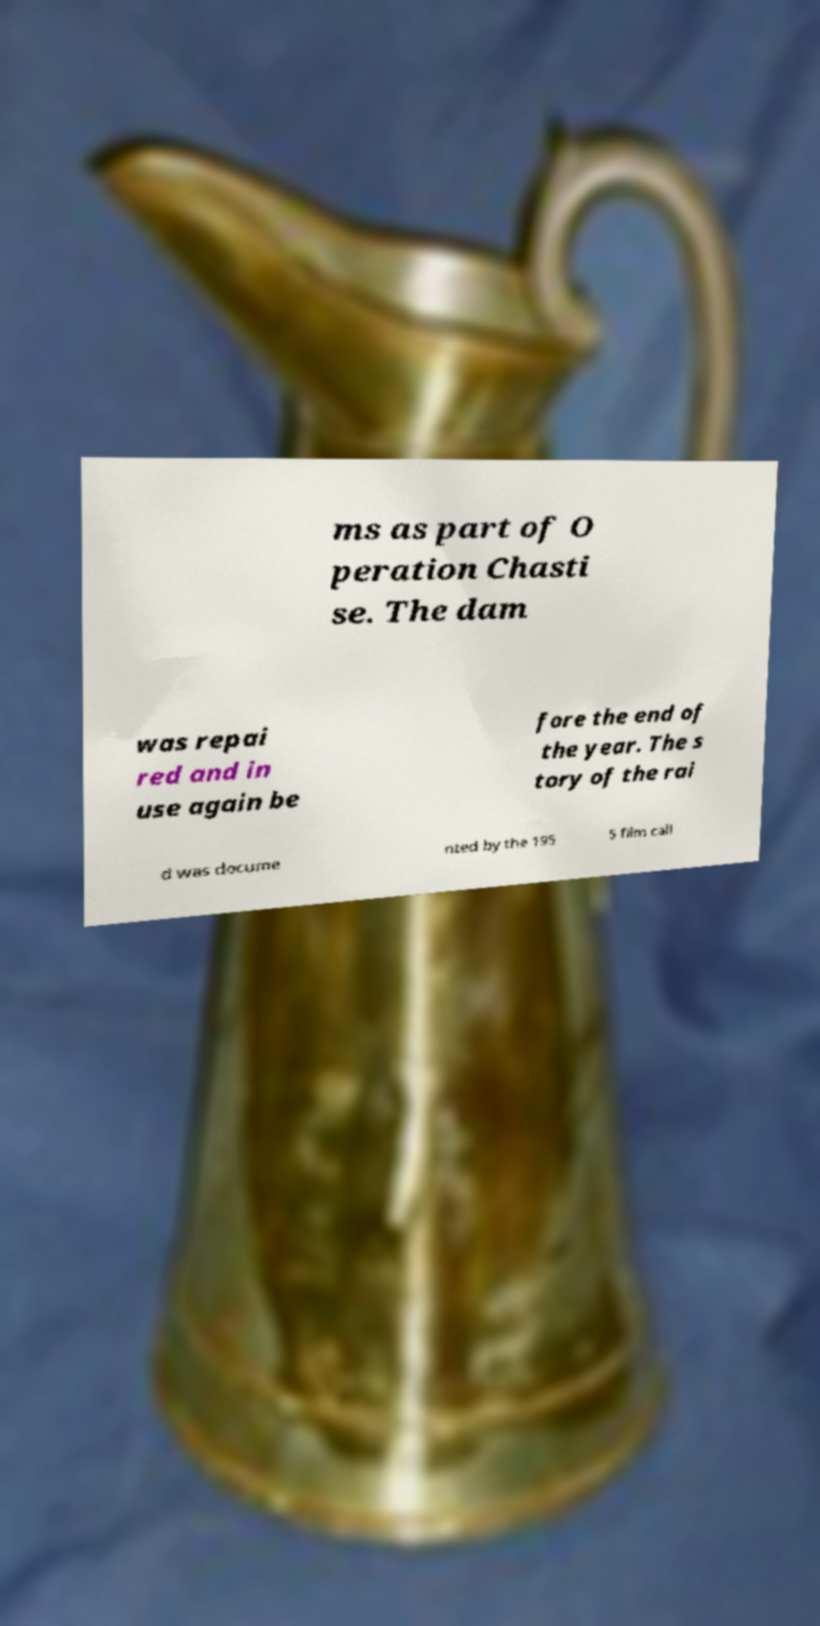Can you accurately transcribe the text from the provided image for me? ms as part of O peration Chasti se. The dam was repai red and in use again be fore the end of the year. The s tory of the rai d was docume nted by the 195 5 film call 